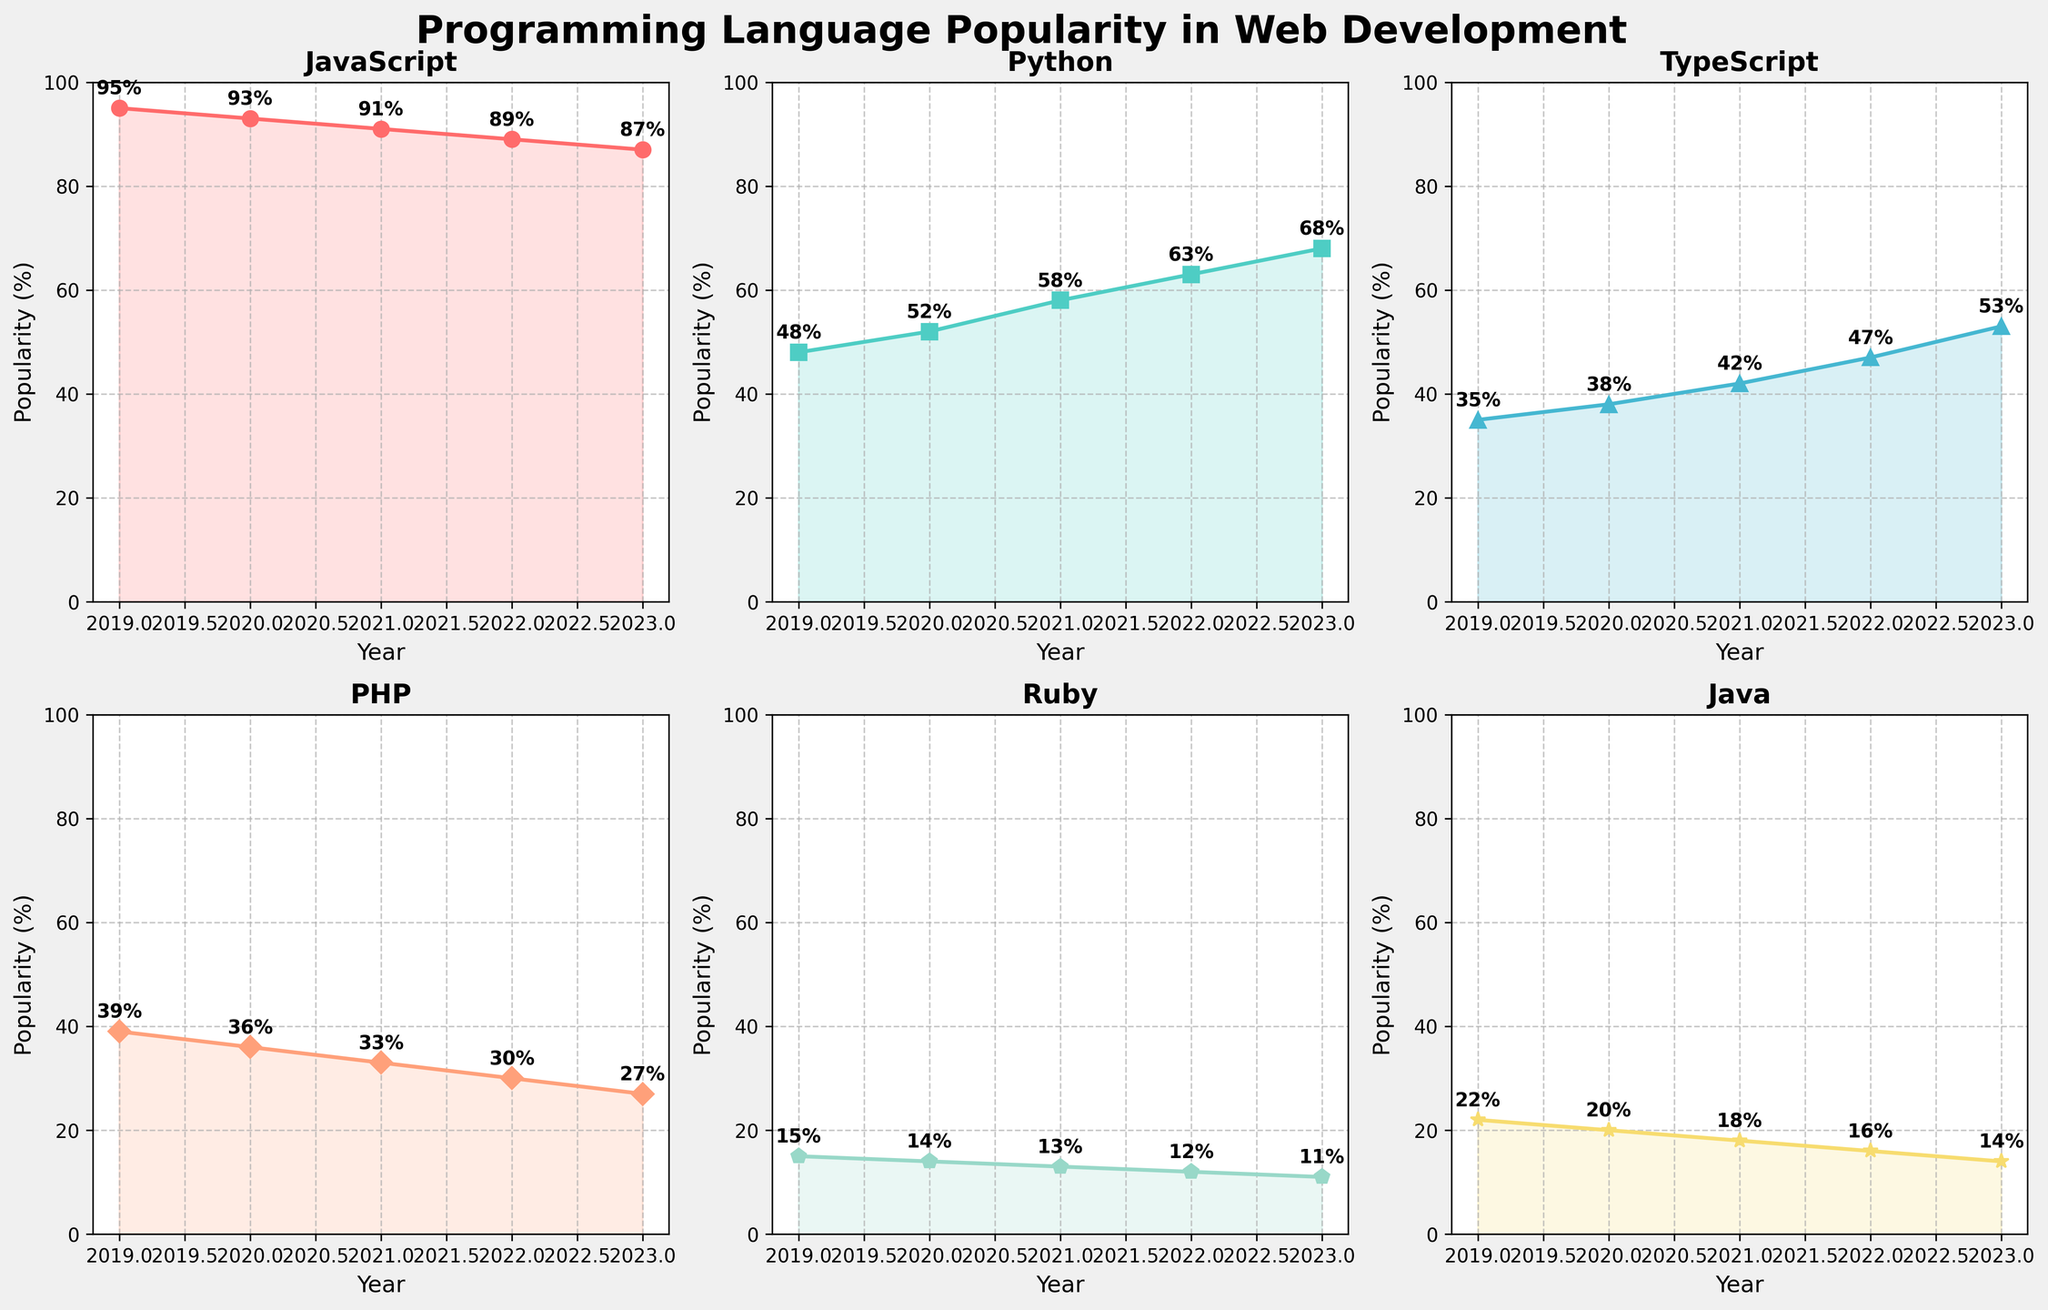What is the title of the entire figure? The title of the entire figure is usually displayed at the top. Here, it should summarize the general theme of the subplots. The title is "Programming Language Popularity in Web Development" based on the suptitle in the code.
Answer: Programming Language Popularity in Web Development Which language had the highest popularity in 2023? Each subplot represents the popularity trend of a programming language over the years. To find the most popular language in 2023, look at the data points for 2023 in each subplot. JavaScript had the highest popularity in 2023 with 87%.
Answer: JavaScript How many programming languages are displayed in total? The code creates subplots for each language and the titles of subplots indicate the languages. Counting the number of subplots, we see 6 languages displayed.
Answer: 6 Which programming languages have shown a consistent increase in popularity over the last 5 years? By analyzing the trend lines in each subplot, identify the languages whose lines continuously rise from 2019 to 2023. Both Python and TypeScript have shown a consistent increase in popularity.
Answer: Python and TypeScript How did PHP's popularity change from 2019 to 2023? Look at PHP's subplot and compare the data point in 2019 with that in 2023. PHP's popularity decreased from 39% to 27% over the period.
Answer: Decreased from 39% to 27% What is the difference in popularity between JavaScript and TypeScript in 2023? To find this, subtract the popularity percentage of TypeScript from that of JavaScript in 2023. JavaScript is 87% and TypeScript is 53%, so the difference is 34%.
Answer: 34% Which year saw the most significant increase in Python's popularity? Look at the subplot for Python and find the year-to-year changes in popularity. The largest increase is between 2021 and 2022 where it jumped from 58% to 63%.
Answer: Between 2021 and 2022 Between 2020 and 2022, how many languages experienced a decline in popularity? By checking each subplot, count the number of languages whose trend lines go down between the years 2020 and 2022. JavaScript, PHP, Ruby, and Java experienced a decline.
Answer: 4 What is the average popularity of Ruby over the 5-year period? To find the average, sum up Ruby's popularity percentages from each year and divide by 5. That's (15 + 14 + 13 + 12 + 11) / 5 = 13%.
Answer: 13% Which two languages had their popularity percentages closest to each other in 2019? Compare the 2019 data points across subplots and find the two closest. TypeScript and PHP have the closest values with 35% and 39%, respectively.
Answer: TypeScript and PHP 